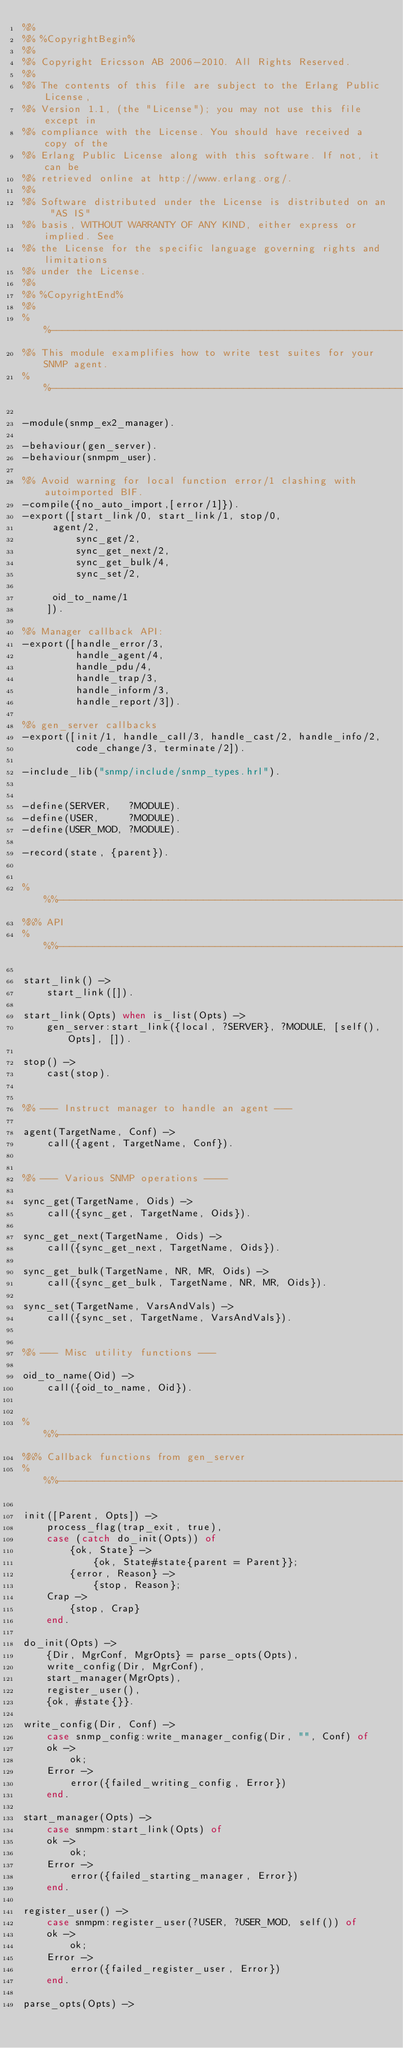Convert code to text. <code><loc_0><loc_0><loc_500><loc_500><_Erlang_>%%
%% %CopyrightBegin%
%% 
%% Copyright Ericsson AB 2006-2010. All Rights Reserved.
%% 
%% The contents of this file are subject to the Erlang Public License,
%% Version 1.1, (the "License"); you may not use this file except in
%% compliance with the License. You should have received a copy of the
%% Erlang Public License along with this software. If not, it can be
%% retrieved online at http://www.erlang.org/.
%% 
%% Software distributed under the License is distributed on an "AS IS"
%% basis, WITHOUT WARRANTY OF ANY KIND, either express or implied. See
%% the License for the specific language governing rights and limitations
%% under the License.
%% 
%% %CopyrightEnd%
%%
%%----------------------------------------------------------------------
%% This module examplifies how to write test suites for your SNMP agent.
%%----------------------------------------------------------------------

-module(snmp_ex2_manager).

-behaviour(gen_server).
-behaviour(snmpm_user).

%% Avoid warning for local function error/1 clashing with autoimported BIF.
-compile({no_auto_import,[error/1]}).
-export([start_link/0, start_link/1, stop/0,
	 agent/2, 
         sync_get/2, 
         sync_get_next/2, 
         sync_get_bulk/4, 
         sync_set/2, 

	 oid_to_name/1
	]).

%% Manager callback API:
-export([handle_error/3,
         handle_agent/4,
         handle_pdu/4,
         handle_trap/3,
         handle_inform/3,
         handle_report/3]).

%% gen_server callbacks
-export([init/1, handle_call/3, handle_cast/2, handle_info/2,
         code_change/3, terminate/2]).

-include_lib("snmp/include/snmp_types.hrl").


-define(SERVER,   ?MODULE).
-define(USER,     ?MODULE).
-define(USER_MOD, ?MODULE).

-record(state, {parent}).


%%%-------------------------------------------------------------------
%%% API
%%%-------------------------------------------------------------------

start_link() ->
    start_link([]).

start_link(Opts) when is_list(Opts) ->
    gen_server:start_link({local, ?SERVER}, ?MODULE, [self(), Opts], []).

stop() ->
    cast(stop).


%% --- Instruct manager to handle an agent ---

agent(TargetName, Conf) ->
    call({agent, TargetName, Conf}).


%% --- Various SNMP operations ----

sync_get(TargetName, Oids) ->
    call({sync_get, TargetName, Oids}).

sync_get_next(TargetName, Oids) ->
    call({sync_get_next, TargetName, Oids}).

sync_get_bulk(TargetName, NR, MR, Oids) ->
    call({sync_get_bulk, TargetName, NR, MR, Oids}).

sync_set(TargetName, VarsAndVals) ->
    call({sync_set, TargetName, VarsAndVals}).


%% --- Misc utility functions ---

oid_to_name(Oid) ->
    call({oid_to_name, Oid}).


%%%-------------------------------------------------------------------
%%% Callback functions from gen_server
%%%-------------------------------------------------------------------

init([Parent, Opts]) ->
    process_flag(trap_exit, true),
    case (catch do_init(Opts)) of
        {ok, State} ->
            {ok, State#state{parent = Parent}};
        {error, Reason} ->
            {stop, Reason};
	Crap ->
	    {stop, Crap}
    end.

do_init(Opts) ->
    {Dir, MgrConf, MgrOpts} = parse_opts(Opts),
    write_config(Dir, MgrConf),
    start_manager(MgrOpts),
    register_user(),
    {ok, #state{}}.

write_config(Dir, Conf) ->
    case snmp_config:write_manager_config(Dir, "", Conf) of
	ok ->
	    ok;
	Error ->
	    error({failed_writing_config, Error})
    end.

start_manager(Opts) ->
    case snmpm:start_link(Opts) of
	ok ->
	    ok; 
	Error ->
	    error({failed_starting_manager, Error})
    end.

register_user() ->
    case snmpm:register_user(?USER, ?USER_MOD, self()) of
	ok ->
	    ok;
	Error ->
	    error({failed_register_user, Error})
    end.

parse_opts(Opts) -></code> 